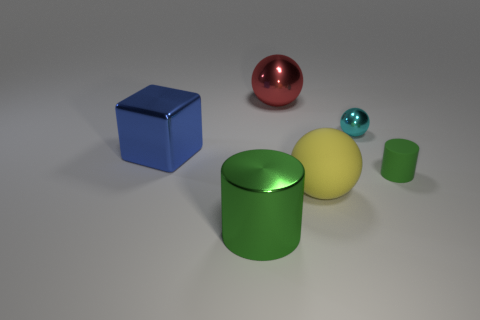How many big green matte blocks are there?
Offer a very short reply. 0. What number of other cyan metallic balls are the same size as the cyan metal sphere?
Provide a succinct answer. 0. What is the material of the cyan sphere?
Make the answer very short. Metal. There is a tiny matte thing; is its color the same as the shiny ball to the left of the large matte thing?
Ensure brevity in your answer.  No. Is there any other thing that has the same size as the blue shiny object?
Keep it short and to the point. Yes. There is a shiny thing that is both on the right side of the big blue metal block and in front of the cyan shiny sphere; what is its size?
Make the answer very short. Large. There is a large green object that is made of the same material as the small sphere; what shape is it?
Your answer should be very brief. Cylinder. Is the large red sphere made of the same material as the cylinder that is on the left side of the tiny cyan metal ball?
Ensure brevity in your answer.  Yes. There is a large matte object in front of the big blue object; are there any rubber spheres to the left of it?
Give a very brief answer. No. What material is the big green thing that is the same shape as the small green matte object?
Offer a terse response. Metal. 